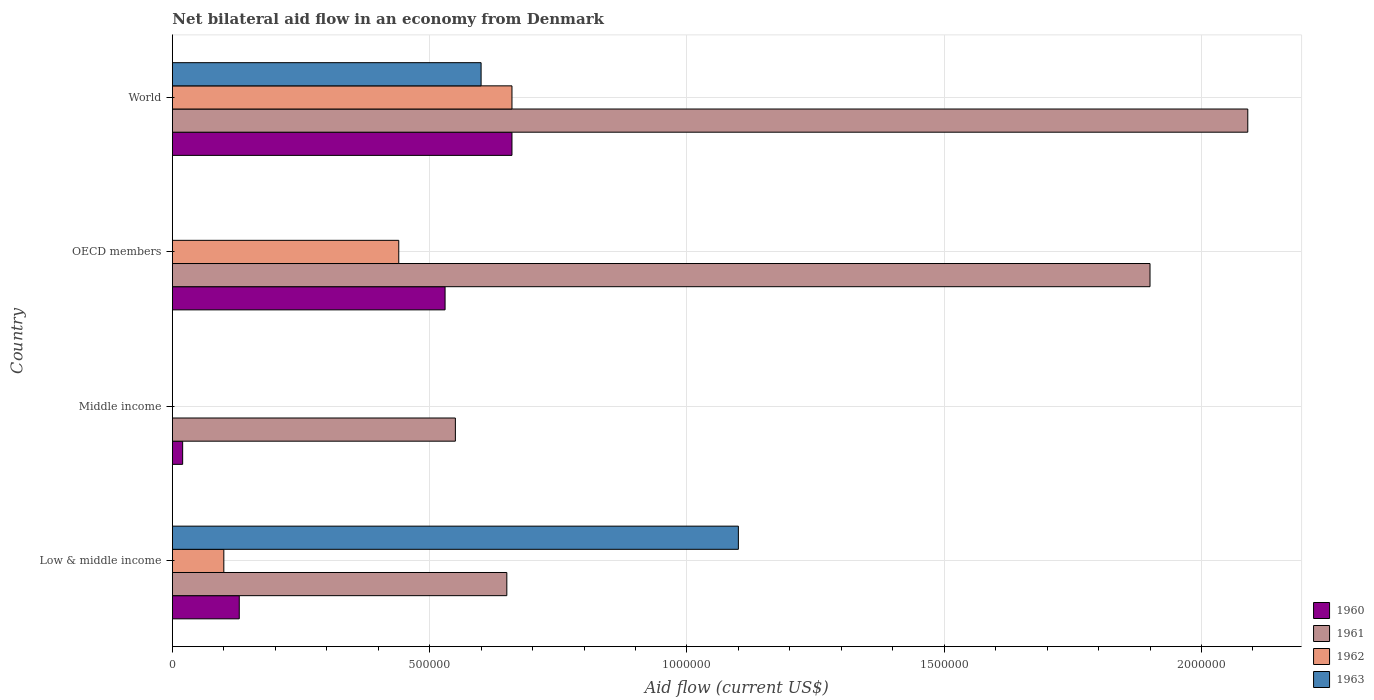Are the number of bars per tick equal to the number of legend labels?
Make the answer very short. No. How many bars are there on the 3rd tick from the bottom?
Provide a succinct answer. 3. What is the net bilateral aid flow in 1961 in World?
Provide a succinct answer. 2.09e+06. Across all countries, what is the maximum net bilateral aid flow in 1961?
Provide a succinct answer. 2.09e+06. In which country was the net bilateral aid flow in 1962 maximum?
Your response must be concise. World. What is the total net bilateral aid flow in 1963 in the graph?
Ensure brevity in your answer.  1.70e+06. What is the difference between the net bilateral aid flow in 1960 in OECD members and the net bilateral aid flow in 1963 in Low & middle income?
Make the answer very short. -5.70e+05. What is the average net bilateral aid flow in 1963 per country?
Offer a terse response. 4.25e+05. What is the difference between the net bilateral aid flow in 1963 and net bilateral aid flow in 1961 in Low & middle income?
Your response must be concise. 4.50e+05. In how many countries, is the net bilateral aid flow in 1963 greater than 1800000 US$?
Offer a terse response. 0. What is the ratio of the net bilateral aid flow in 1961 in OECD members to that in World?
Your response must be concise. 0.91. What is the difference between the highest and the second highest net bilateral aid flow in 1961?
Ensure brevity in your answer.  1.90e+05. What is the difference between the highest and the lowest net bilateral aid flow in 1960?
Make the answer very short. 6.40e+05. In how many countries, is the net bilateral aid flow in 1962 greater than the average net bilateral aid flow in 1962 taken over all countries?
Provide a short and direct response. 2. Is the sum of the net bilateral aid flow in 1961 in Middle income and World greater than the maximum net bilateral aid flow in 1963 across all countries?
Ensure brevity in your answer.  Yes. Is it the case that in every country, the sum of the net bilateral aid flow in 1960 and net bilateral aid flow in 1962 is greater than the sum of net bilateral aid flow in 1963 and net bilateral aid flow in 1961?
Your answer should be compact. No. Are all the bars in the graph horizontal?
Your answer should be compact. Yes. How many countries are there in the graph?
Offer a very short reply. 4. Does the graph contain any zero values?
Ensure brevity in your answer.  Yes. Does the graph contain grids?
Offer a terse response. Yes. How many legend labels are there?
Give a very brief answer. 4. How are the legend labels stacked?
Offer a terse response. Vertical. What is the title of the graph?
Ensure brevity in your answer.  Net bilateral aid flow in an economy from Denmark. Does "2007" appear as one of the legend labels in the graph?
Your response must be concise. No. What is the Aid flow (current US$) in 1960 in Low & middle income?
Make the answer very short. 1.30e+05. What is the Aid flow (current US$) of 1961 in Low & middle income?
Your answer should be compact. 6.50e+05. What is the Aid flow (current US$) in 1963 in Low & middle income?
Provide a succinct answer. 1.10e+06. What is the Aid flow (current US$) of 1961 in Middle income?
Your answer should be very brief. 5.50e+05. What is the Aid flow (current US$) in 1963 in Middle income?
Your answer should be compact. 0. What is the Aid flow (current US$) of 1960 in OECD members?
Make the answer very short. 5.30e+05. What is the Aid flow (current US$) in 1961 in OECD members?
Provide a short and direct response. 1.90e+06. What is the Aid flow (current US$) in 1962 in OECD members?
Keep it short and to the point. 4.40e+05. What is the Aid flow (current US$) of 1963 in OECD members?
Your answer should be very brief. 0. What is the Aid flow (current US$) of 1960 in World?
Provide a short and direct response. 6.60e+05. What is the Aid flow (current US$) in 1961 in World?
Give a very brief answer. 2.09e+06. Across all countries, what is the maximum Aid flow (current US$) of 1961?
Offer a terse response. 2.09e+06. Across all countries, what is the maximum Aid flow (current US$) of 1963?
Provide a succinct answer. 1.10e+06. Across all countries, what is the minimum Aid flow (current US$) of 1961?
Give a very brief answer. 5.50e+05. Across all countries, what is the minimum Aid flow (current US$) of 1962?
Make the answer very short. 0. Across all countries, what is the minimum Aid flow (current US$) of 1963?
Provide a succinct answer. 0. What is the total Aid flow (current US$) in 1960 in the graph?
Ensure brevity in your answer.  1.34e+06. What is the total Aid flow (current US$) of 1961 in the graph?
Give a very brief answer. 5.19e+06. What is the total Aid flow (current US$) of 1962 in the graph?
Ensure brevity in your answer.  1.20e+06. What is the total Aid flow (current US$) in 1963 in the graph?
Provide a short and direct response. 1.70e+06. What is the difference between the Aid flow (current US$) of 1960 in Low & middle income and that in Middle income?
Offer a terse response. 1.10e+05. What is the difference between the Aid flow (current US$) in 1960 in Low & middle income and that in OECD members?
Provide a succinct answer. -4.00e+05. What is the difference between the Aid flow (current US$) in 1961 in Low & middle income and that in OECD members?
Give a very brief answer. -1.25e+06. What is the difference between the Aid flow (current US$) in 1962 in Low & middle income and that in OECD members?
Your answer should be very brief. -3.40e+05. What is the difference between the Aid flow (current US$) of 1960 in Low & middle income and that in World?
Provide a short and direct response. -5.30e+05. What is the difference between the Aid flow (current US$) of 1961 in Low & middle income and that in World?
Make the answer very short. -1.44e+06. What is the difference between the Aid flow (current US$) of 1962 in Low & middle income and that in World?
Ensure brevity in your answer.  -5.60e+05. What is the difference between the Aid flow (current US$) of 1963 in Low & middle income and that in World?
Provide a short and direct response. 5.00e+05. What is the difference between the Aid flow (current US$) in 1960 in Middle income and that in OECD members?
Keep it short and to the point. -5.10e+05. What is the difference between the Aid flow (current US$) of 1961 in Middle income and that in OECD members?
Offer a very short reply. -1.35e+06. What is the difference between the Aid flow (current US$) in 1960 in Middle income and that in World?
Ensure brevity in your answer.  -6.40e+05. What is the difference between the Aid flow (current US$) in 1961 in Middle income and that in World?
Your answer should be compact. -1.54e+06. What is the difference between the Aid flow (current US$) of 1960 in OECD members and that in World?
Provide a short and direct response. -1.30e+05. What is the difference between the Aid flow (current US$) of 1961 in OECD members and that in World?
Your answer should be very brief. -1.90e+05. What is the difference between the Aid flow (current US$) in 1962 in OECD members and that in World?
Provide a succinct answer. -2.20e+05. What is the difference between the Aid flow (current US$) of 1960 in Low & middle income and the Aid flow (current US$) of 1961 in Middle income?
Keep it short and to the point. -4.20e+05. What is the difference between the Aid flow (current US$) of 1960 in Low & middle income and the Aid flow (current US$) of 1961 in OECD members?
Offer a very short reply. -1.77e+06. What is the difference between the Aid flow (current US$) in 1960 in Low & middle income and the Aid flow (current US$) in 1962 in OECD members?
Keep it short and to the point. -3.10e+05. What is the difference between the Aid flow (current US$) in 1960 in Low & middle income and the Aid flow (current US$) in 1961 in World?
Ensure brevity in your answer.  -1.96e+06. What is the difference between the Aid flow (current US$) in 1960 in Low & middle income and the Aid flow (current US$) in 1962 in World?
Ensure brevity in your answer.  -5.30e+05. What is the difference between the Aid flow (current US$) in 1960 in Low & middle income and the Aid flow (current US$) in 1963 in World?
Offer a very short reply. -4.70e+05. What is the difference between the Aid flow (current US$) in 1961 in Low & middle income and the Aid flow (current US$) in 1963 in World?
Provide a succinct answer. 5.00e+04. What is the difference between the Aid flow (current US$) of 1962 in Low & middle income and the Aid flow (current US$) of 1963 in World?
Keep it short and to the point. -5.00e+05. What is the difference between the Aid flow (current US$) of 1960 in Middle income and the Aid flow (current US$) of 1961 in OECD members?
Offer a very short reply. -1.88e+06. What is the difference between the Aid flow (current US$) of 1960 in Middle income and the Aid flow (current US$) of 1962 in OECD members?
Ensure brevity in your answer.  -4.20e+05. What is the difference between the Aid flow (current US$) of 1961 in Middle income and the Aid flow (current US$) of 1962 in OECD members?
Offer a terse response. 1.10e+05. What is the difference between the Aid flow (current US$) in 1960 in Middle income and the Aid flow (current US$) in 1961 in World?
Offer a very short reply. -2.07e+06. What is the difference between the Aid flow (current US$) in 1960 in Middle income and the Aid flow (current US$) in 1962 in World?
Keep it short and to the point. -6.40e+05. What is the difference between the Aid flow (current US$) of 1960 in Middle income and the Aid flow (current US$) of 1963 in World?
Your answer should be very brief. -5.80e+05. What is the difference between the Aid flow (current US$) of 1961 in Middle income and the Aid flow (current US$) of 1963 in World?
Provide a short and direct response. -5.00e+04. What is the difference between the Aid flow (current US$) in 1960 in OECD members and the Aid flow (current US$) in 1961 in World?
Give a very brief answer. -1.56e+06. What is the difference between the Aid flow (current US$) of 1960 in OECD members and the Aid flow (current US$) of 1962 in World?
Offer a very short reply. -1.30e+05. What is the difference between the Aid flow (current US$) of 1960 in OECD members and the Aid flow (current US$) of 1963 in World?
Your response must be concise. -7.00e+04. What is the difference between the Aid flow (current US$) of 1961 in OECD members and the Aid flow (current US$) of 1962 in World?
Ensure brevity in your answer.  1.24e+06. What is the difference between the Aid flow (current US$) of 1961 in OECD members and the Aid flow (current US$) of 1963 in World?
Offer a terse response. 1.30e+06. What is the average Aid flow (current US$) of 1960 per country?
Provide a short and direct response. 3.35e+05. What is the average Aid flow (current US$) of 1961 per country?
Make the answer very short. 1.30e+06. What is the average Aid flow (current US$) of 1962 per country?
Your response must be concise. 3.00e+05. What is the average Aid flow (current US$) in 1963 per country?
Offer a terse response. 4.25e+05. What is the difference between the Aid flow (current US$) in 1960 and Aid flow (current US$) in 1961 in Low & middle income?
Offer a terse response. -5.20e+05. What is the difference between the Aid flow (current US$) in 1960 and Aid flow (current US$) in 1962 in Low & middle income?
Make the answer very short. 3.00e+04. What is the difference between the Aid flow (current US$) of 1960 and Aid flow (current US$) of 1963 in Low & middle income?
Your answer should be very brief. -9.70e+05. What is the difference between the Aid flow (current US$) in 1961 and Aid flow (current US$) in 1963 in Low & middle income?
Provide a succinct answer. -4.50e+05. What is the difference between the Aid flow (current US$) of 1960 and Aid flow (current US$) of 1961 in Middle income?
Your answer should be very brief. -5.30e+05. What is the difference between the Aid flow (current US$) in 1960 and Aid flow (current US$) in 1961 in OECD members?
Your answer should be very brief. -1.37e+06. What is the difference between the Aid flow (current US$) in 1961 and Aid flow (current US$) in 1962 in OECD members?
Offer a very short reply. 1.46e+06. What is the difference between the Aid flow (current US$) in 1960 and Aid flow (current US$) in 1961 in World?
Ensure brevity in your answer.  -1.43e+06. What is the difference between the Aid flow (current US$) of 1961 and Aid flow (current US$) of 1962 in World?
Make the answer very short. 1.43e+06. What is the difference between the Aid flow (current US$) in 1961 and Aid flow (current US$) in 1963 in World?
Provide a short and direct response. 1.49e+06. What is the difference between the Aid flow (current US$) in 1962 and Aid flow (current US$) in 1963 in World?
Provide a succinct answer. 6.00e+04. What is the ratio of the Aid flow (current US$) in 1960 in Low & middle income to that in Middle income?
Keep it short and to the point. 6.5. What is the ratio of the Aid flow (current US$) of 1961 in Low & middle income to that in Middle income?
Provide a short and direct response. 1.18. What is the ratio of the Aid flow (current US$) of 1960 in Low & middle income to that in OECD members?
Make the answer very short. 0.25. What is the ratio of the Aid flow (current US$) in 1961 in Low & middle income to that in OECD members?
Your response must be concise. 0.34. What is the ratio of the Aid flow (current US$) in 1962 in Low & middle income to that in OECD members?
Provide a short and direct response. 0.23. What is the ratio of the Aid flow (current US$) in 1960 in Low & middle income to that in World?
Offer a terse response. 0.2. What is the ratio of the Aid flow (current US$) of 1961 in Low & middle income to that in World?
Provide a short and direct response. 0.31. What is the ratio of the Aid flow (current US$) of 1962 in Low & middle income to that in World?
Provide a succinct answer. 0.15. What is the ratio of the Aid flow (current US$) in 1963 in Low & middle income to that in World?
Make the answer very short. 1.83. What is the ratio of the Aid flow (current US$) of 1960 in Middle income to that in OECD members?
Your response must be concise. 0.04. What is the ratio of the Aid flow (current US$) in 1961 in Middle income to that in OECD members?
Ensure brevity in your answer.  0.29. What is the ratio of the Aid flow (current US$) of 1960 in Middle income to that in World?
Provide a succinct answer. 0.03. What is the ratio of the Aid flow (current US$) in 1961 in Middle income to that in World?
Give a very brief answer. 0.26. What is the ratio of the Aid flow (current US$) in 1960 in OECD members to that in World?
Your response must be concise. 0.8. What is the ratio of the Aid flow (current US$) in 1961 in OECD members to that in World?
Your answer should be very brief. 0.91. What is the difference between the highest and the second highest Aid flow (current US$) in 1961?
Make the answer very short. 1.90e+05. What is the difference between the highest and the second highest Aid flow (current US$) of 1962?
Offer a very short reply. 2.20e+05. What is the difference between the highest and the lowest Aid flow (current US$) of 1960?
Ensure brevity in your answer.  6.40e+05. What is the difference between the highest and the lowest Aid flow (current US$) of 1961?
Your response must be concise. 1.54e+06. What is the difference between the highest and the lowest Aid flow (current US$) of 1962?
Make the answer very short. 6.60e+05. What is the difference between the highest and the lowest Aid flow (current US$) of 1963?
Offer a terse response. 1.10e+06. 